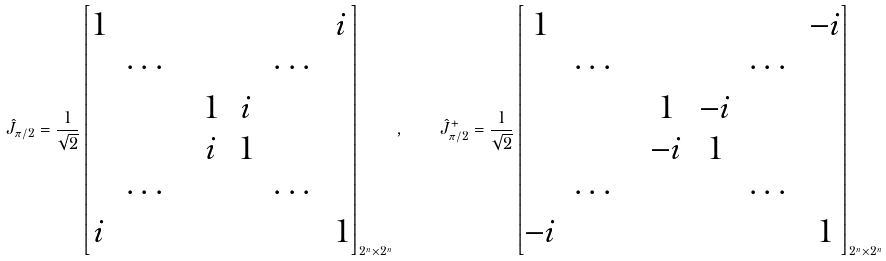<formula> <loc_0><loc_0><loc_500><loc_500>\hat { J } _ { \pi / 2 } = \frac { 1 } { \sqrt { 2 } } \begin{bmatrix} 1 & & & & & & i \\ & \cdots & & & & \cdots & \\ & & & 1 & i & & \\ & & & i & 1 & & \\ & \cdots & & & & \cdots & \\ i & & & & & & 1 \end{bmatrix} _ { 2 ^ { n } \times 2 ^ { n } } , \quad \hat { J } ^ { + } _ { \pi / 2 } = \frac { 1 } { \sqrt { 2 } } \begin{bmatrix} 1 & & & & & & - i \\ & \cdots & & & & \cdots & \\ & & & 1 & - i & & \\ & & & - i & 1 & & \\ & \cdots & & & & \cdots & \\ - i & & & & & & 1 \end{bmatrix} _ { 2 ^ { n } \times 2 ^ { n } }</formula> 